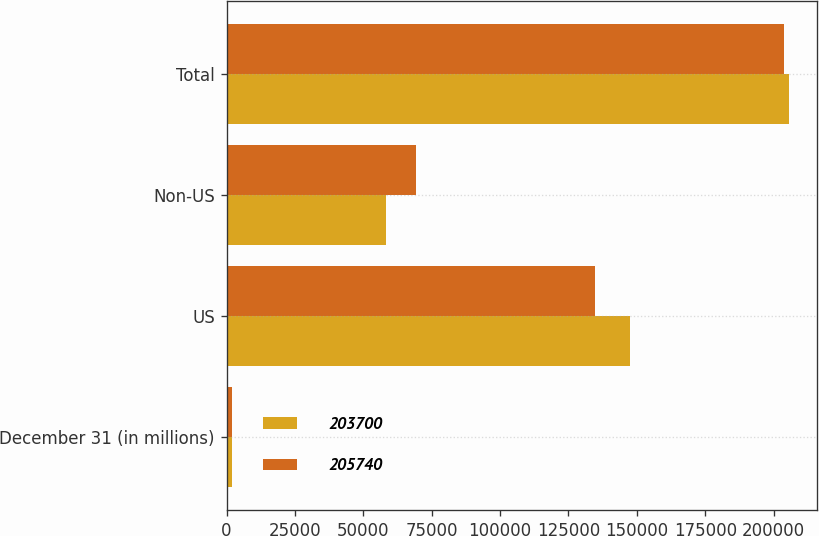Convert chart. <chart><loc_0><loc_0><loc_500><loc_500><stacked_bar_chart><ecel><fcel>December 31 (in millions)<fcel>US<fcel>Non-US<fcel>Total<nl><fcel>203700<fcel>2008<fcel>147493<fcel>58247<fcel>205740<nl><fcel>205740<fcel>2007<fcel>134529<fcel>69171<fcel>203700<nl></chart> 